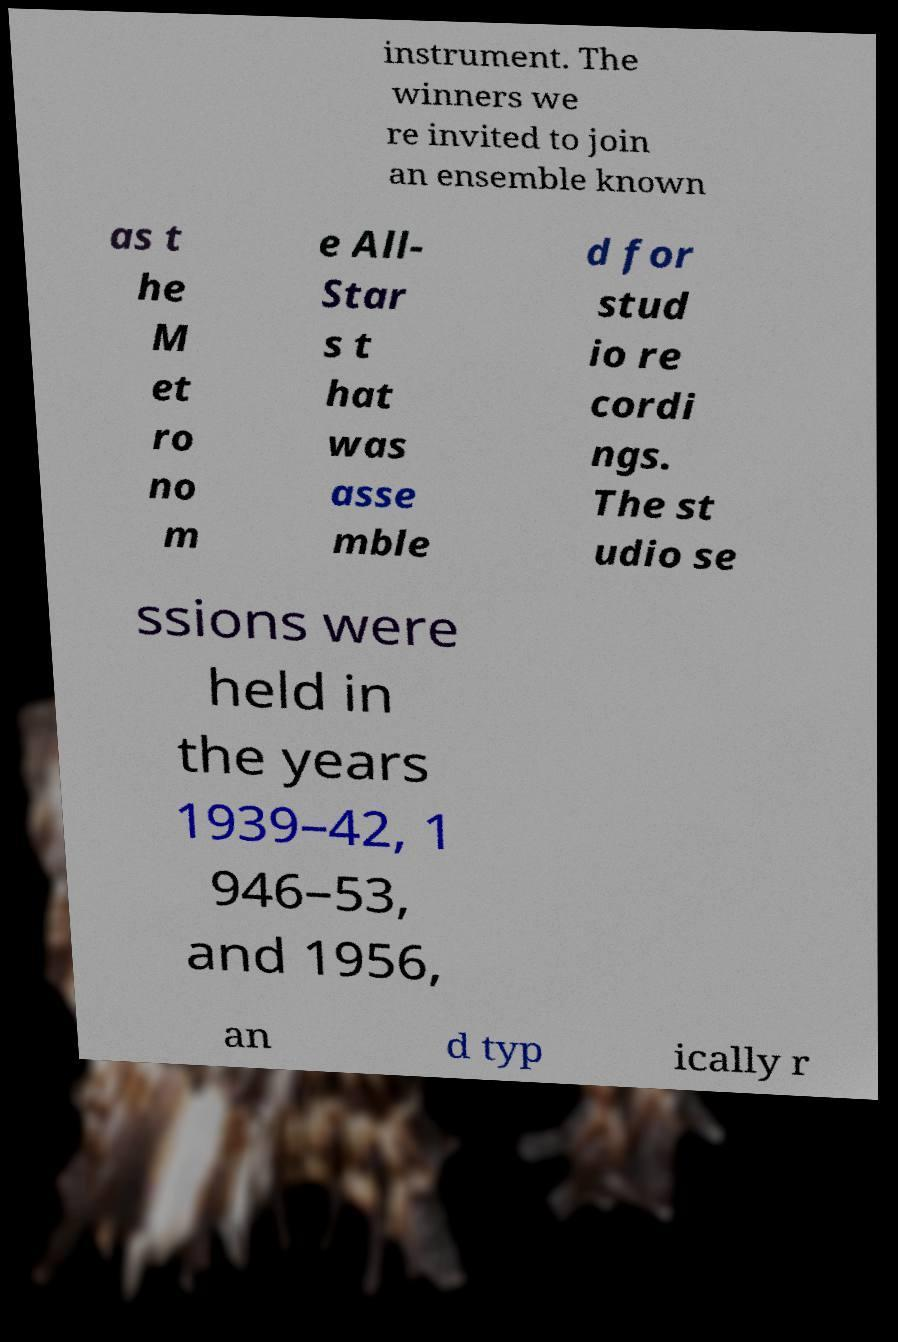Please read and relay the text visible in this image. What does it say? instrument. The winners we re invited to join an ensemble known as t he M et ro no m e All- Star s t hat was asse mble d for stud io re cordi ngs. The st udio se ssions were held in the years 1939–42, 1 946–53, and 1956, an d typ ically r 